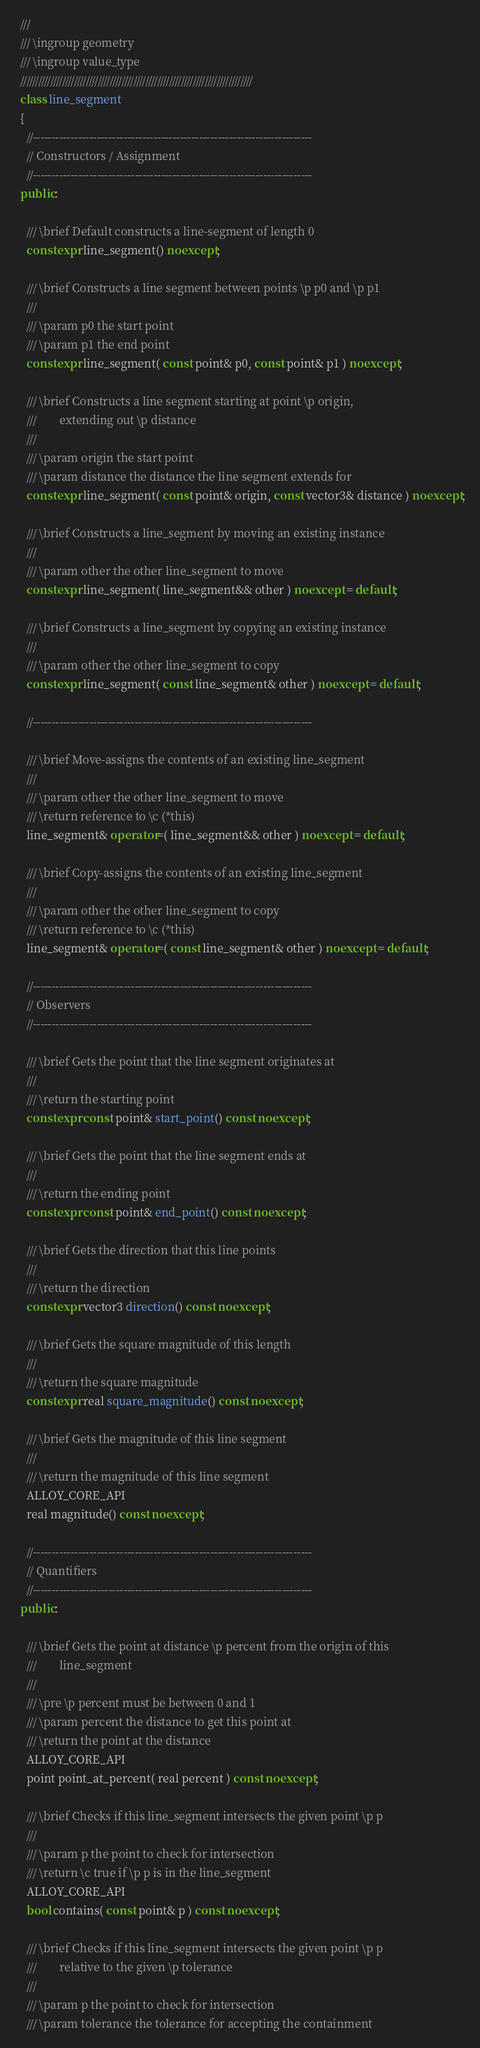Convert code to text. <code><loc_0><loc_0><loc_500><loc_500><_C++_>  ///
  /// \ingroup geometry
  /// \ingroup value_type
  //////////////////////////////////////////////////////////////////////////////
  class line_segment
  {
    //--------------------------------------------------------------------------
    // Constructors / Assignment
    //--------------------------------------------------------------------------
  public:

    /// \brief Default constructs a line-segment of length 0
    constexpr line_segment() noexcept;

    /// \brief Constructs a line segment between points \p p0 and \p p1
    ///
    /// \param p0 the start point
    /// \param p1 the end point
    constexpr line_segment( const point& p0, const point& p1 ) noexcept;

    /// \brief Constructs a line segment starting at point \p origin,
    ///        extending out \p distance
    ///
    /// \param origin the start point
    /// \param distance the distance the line segment extends for
    constexpr line_segment( const point& origin, const vector3& distance ) noexcept;

    /// \brief Constructs a line_segment by moving an existing instance
    ///
    /// \param other the other line_segment to move
    constexpr line_segment( line_segment&& other ) noexcept = default;

    /// \brief Constructs a line_segment by copying an existing instance
    ///
    /// \param other the other line_segment to copy
    constexpr line_segment( const line_segment& other ) noexcept = default;

    //--------------------------------------------------------------------------

    /// \brief Move-assigns the contents of an existing line_segment
    ///
    /// \param other the other line_segment to move
    /// \return reference to \c (*this)
    line_segment& operator=( line_segment&& other ) noexcept = default;

    /// \brief Copy-assigns the contents of an existing line_segment
    ///
    /// \param other the other line_segment to copy
    /// \return reference to \c (*this)
    line_segment& operator=( const line_segment& other ) noexcept = default;

    //--------------------------------------------------------------------------
    // Observers
    //--------------------------------------------------------------------------

    /// \brief Gets the point that the line segment originates at
    ///
    /// \return the starting point
    constexpr const point& start_point() const noexcept;

    /// \brief Gets the point that the line segment ends at
    ///
    /// \return the ending point
    constexpr const point& end_point() const noexcept;

    /// \brief Gets the direction that this line points
    ///
    /// \return the direction
    constexpr vector3 direction() const noexcept;

    /// \brief Gets the square magnitude of this length
    ///
    /// \return the square magnitude
    constexpr real square_magnitude() const noexcept;

    /// \brief Gets the magnitude of this line segment
    ///
    /// \return the magnitude of this line segment
    ALLOY_CORE_API
    real magnitude() const noexcept;

    //--------------------------------------------------------------------------
    // Quantifiers
    //--------------------------------------------------------------------------
  public:

    /// \brief Gets the point at distance \p percent from the origin of this
    ///        line_segment
    ///
    /// \pre \p percent must be between 0 and 1
    /// \param percent the distance to get this point at
    /// \return the point at the distance
    ALLOY_CORE_API
    point point_at_percent( real percent ) const noexcept;

    /// \brief Checks if this line_segment intersects the given point \p p
    ///
    /// \param p the point to check for intersection
    /// \return \c true if \p p is in the line_segment
    ALLOY_CORE_API
    bool contains( const point& p ) const noexcept;

    /// \brief Checks if this line_segment intersects the given point \p p
    ///        relative to the given \p tolerance
    ///
    /// \param p the point to check for intersection
    /// \param tolerance the tolerance for accepting the containment</code> 